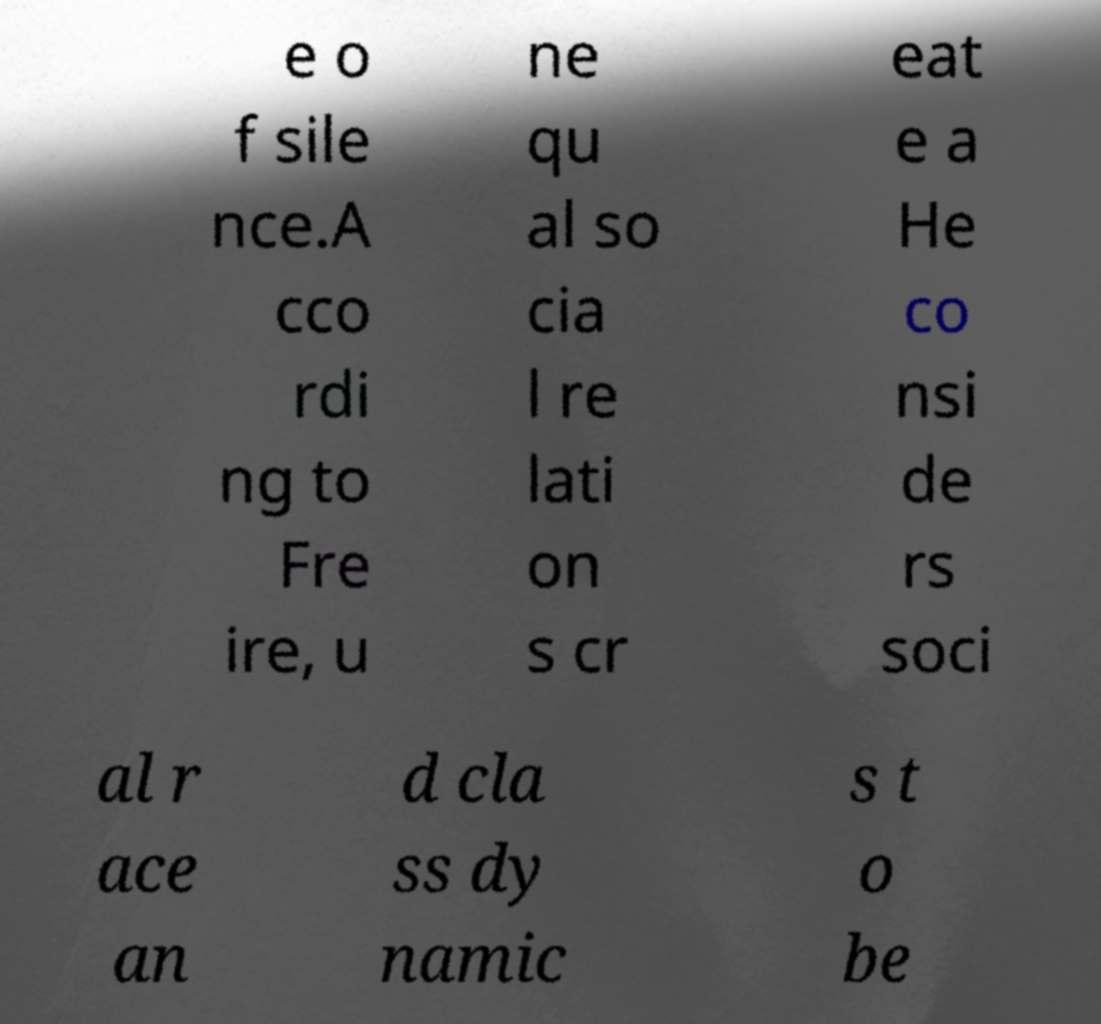Could you extract and type out the text from this image? e o f sile nce.A cco rdi ng to Fre ire, u ne qu al so cia l re lati on s cr eat e a He co nsi de rs soci al r ace an d cla ss dy namic s t o be 